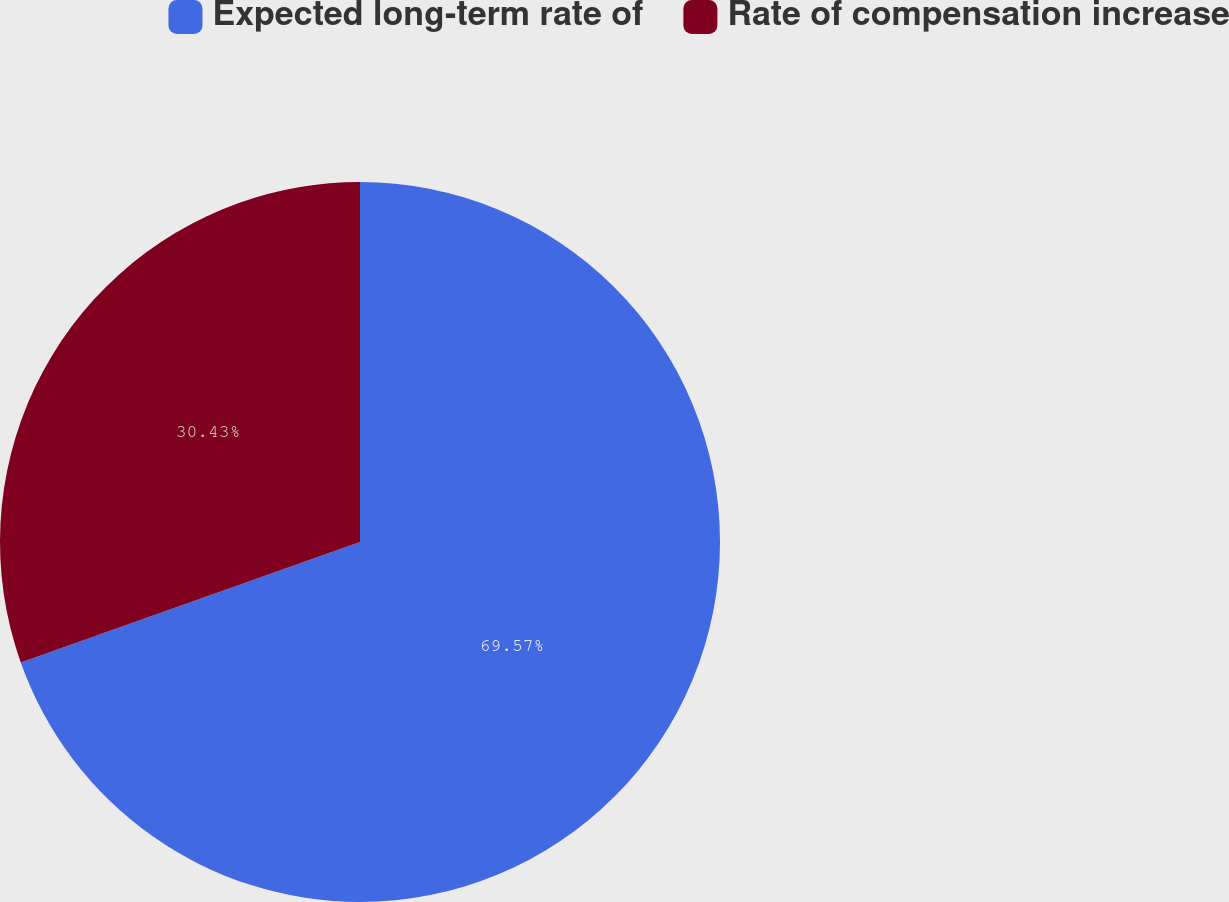<chart> <loc_0><loc_0><loc_500><loc_500><pie_chart><fcel>Expected long-term rate of<fcel>Rate of compensation increase<nl><fcel>69.57%<fcel>30.43%<nl></chart> 